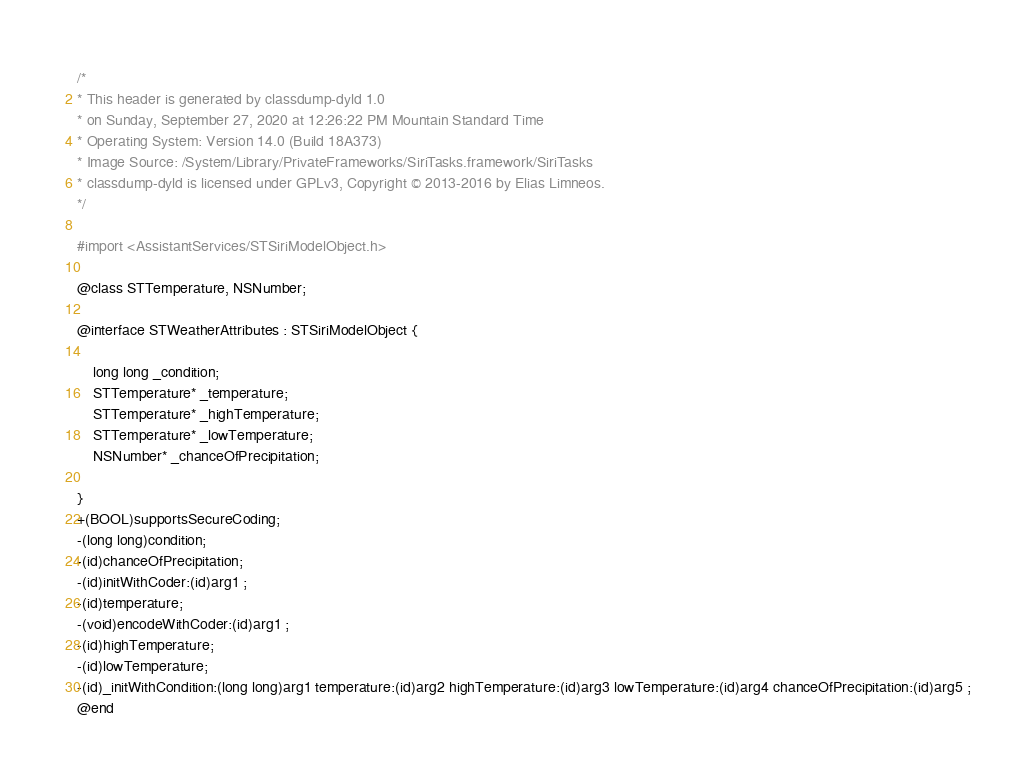<code> <loc_0><loc_0><loc_500><loc_500><_C_>/*
* This header is generated by classdump-dyld 1.0
* on Sunday, September 27, 2020 at 12:26:22 PM Mountain Standard Time
* Operating System: Version 14.0 (Build 18A373)
* Image Source: /System/Library/PrivateFrameworks/SiriTasks.framework/SiriTasks
* classdump-dyld is licensed under GPLv3, Copyright © 2013-2016 by Elias Limneos.
*/

#import <AssistantServices/STSiriModelObject.h>

@class STTemperature, NSNumber;

@interface STWeatherAttributes : STSiriModelObject {

	long long _condition;
	STTemperature* _temperature;
	STTemperature* _highTemperature;
	STTemperature* _lowTemperature;
	NSNumber* _chanceOfPrecipitation;

}
+(BOOL)supportsSecureCoding;
-(long long)condition;
-(id)chanceOfPrecipitation;
-(id)initWithCoder:(id)arg1 ;
-(id)temperature;
-(void)encodeWithCoder:(id)arg1 ;
-(id)highTemperature;
-(id)lowTemperature;
-(id)_initWithCondition:(long long)arg1 temperature:(id)arg2 highTemperature:(id)arg3 lowTemperature:(id)arg4 chanceOfPrecipitation:(id)arg5 ;
@end

</code> 